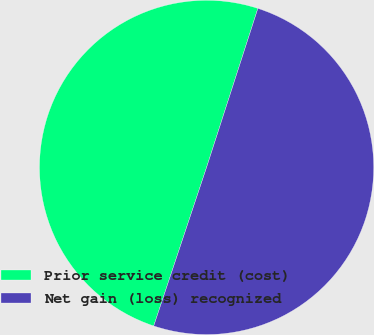<chart> <loc_0><loc_0><loc_500><loc_500><pie_chart><fcel>Prior service credit (cost)<fcel>Net gain (loss) recognized<nl><fcel>49.85%<fcel>50.15%<nl></chart> 